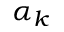Convert formula to latex. <formula><loc_0><loc_0><loc_500><loc_500>\alpha _ { k }</formula> 